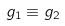Convert formula to latex. <formula><loc_0><loc_0><loc_500><loc_500>g _ { 1 } \equiv g _ { 2 } \ \</formula> 